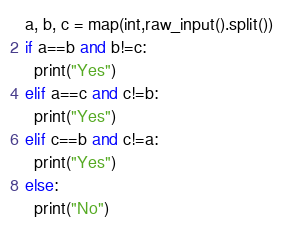Convert code to text. <code><loc_0><loc_0><loc_500><loc_500><_Python_>a, b, c = map(int,raw_input().split())
if a==b and b!=c:
  print("Yes")
elif a==c and c!=b:
  print("Yes")
elif c==b and c!=a:
  print("Yes")
else:
  print("No")
</code> 